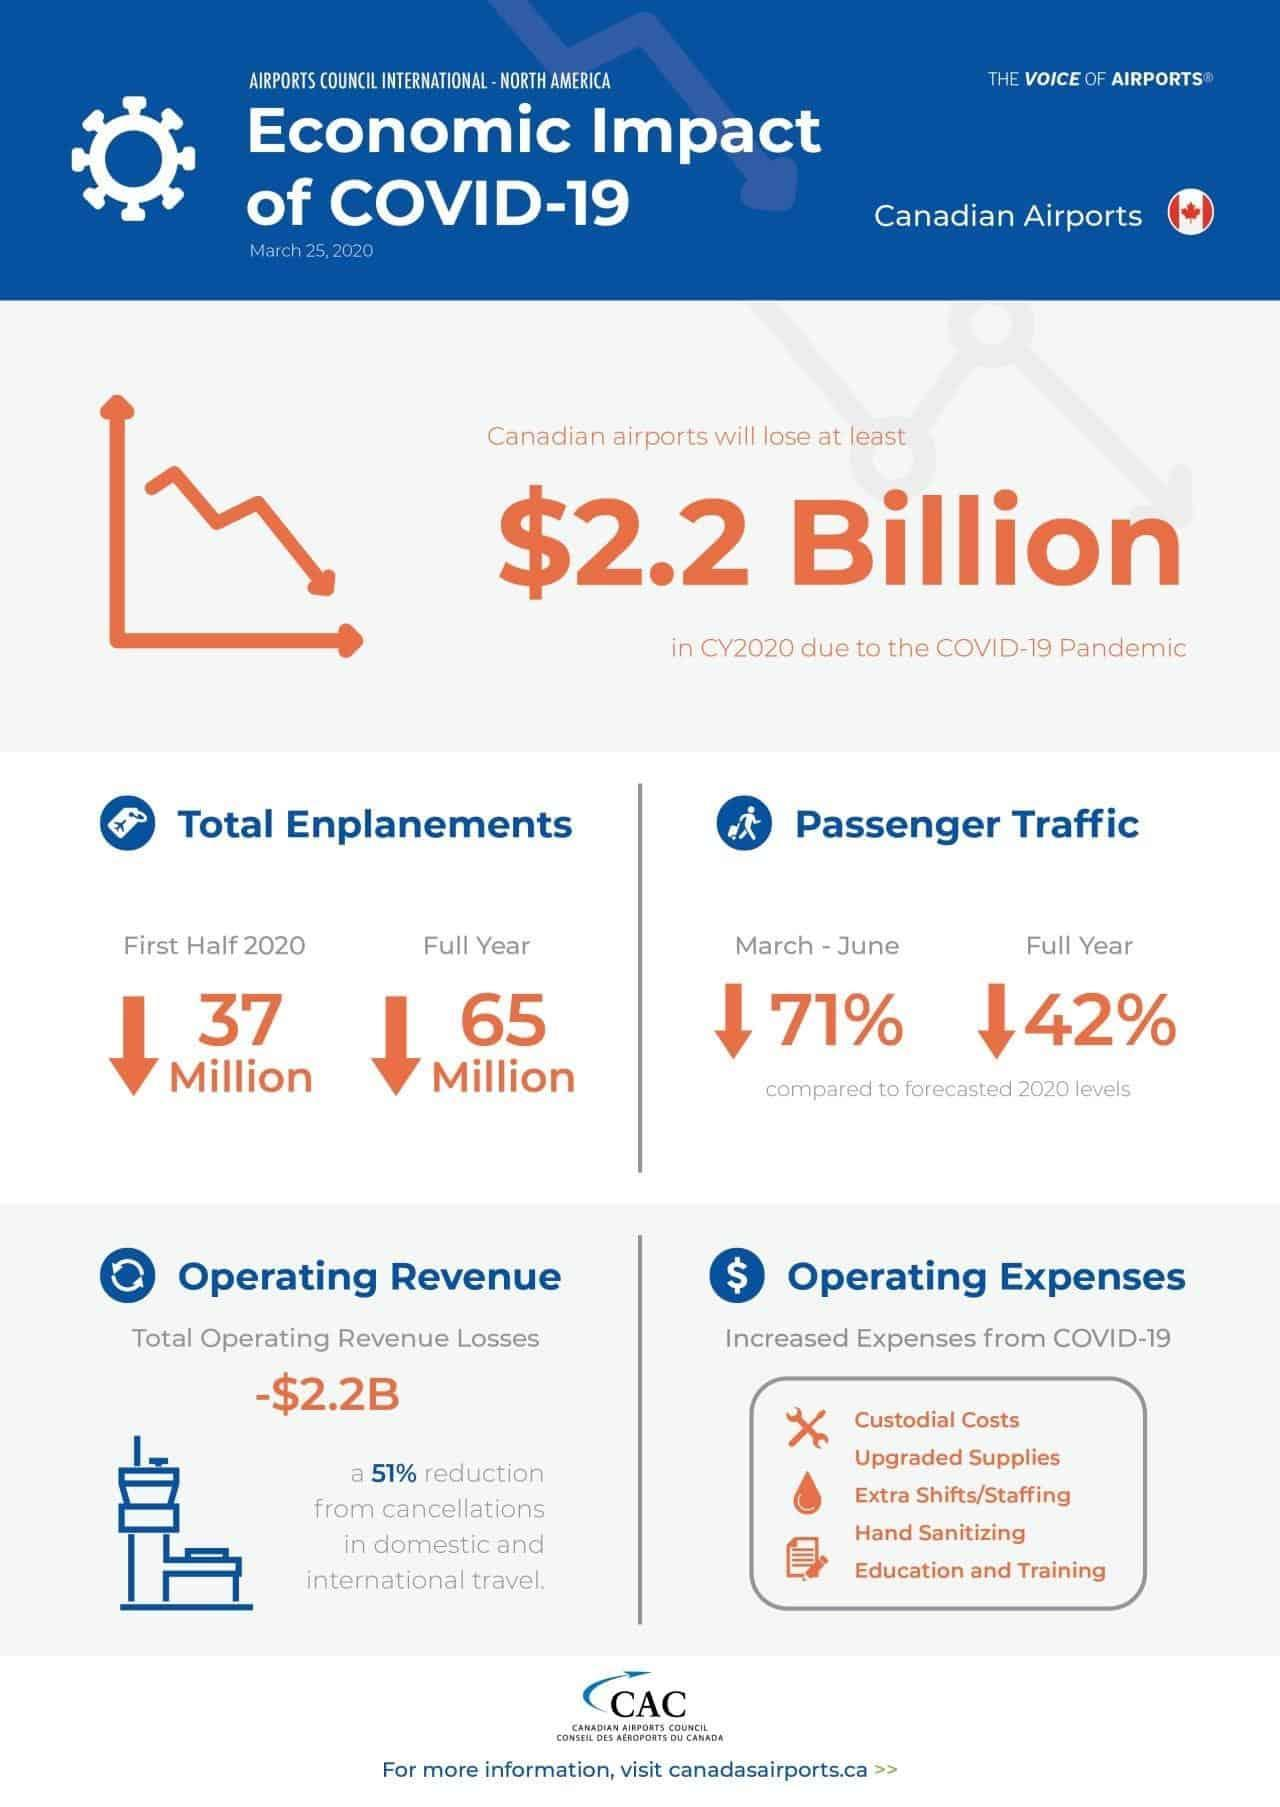What is the percentage decrease in the passenger traffic in Canadian airports due to the COVID-19 pandemic in 2020?
Answer the question with a short phrase. 42% What is the decrease in the total enplanements in Canadian airports due to the COVID-19 pandemic in the first half of 2020? 37 Million What is the decrease in the total enplanements in Canadian airports due to the COVID-19 pandemic in 2020? 65 Million 